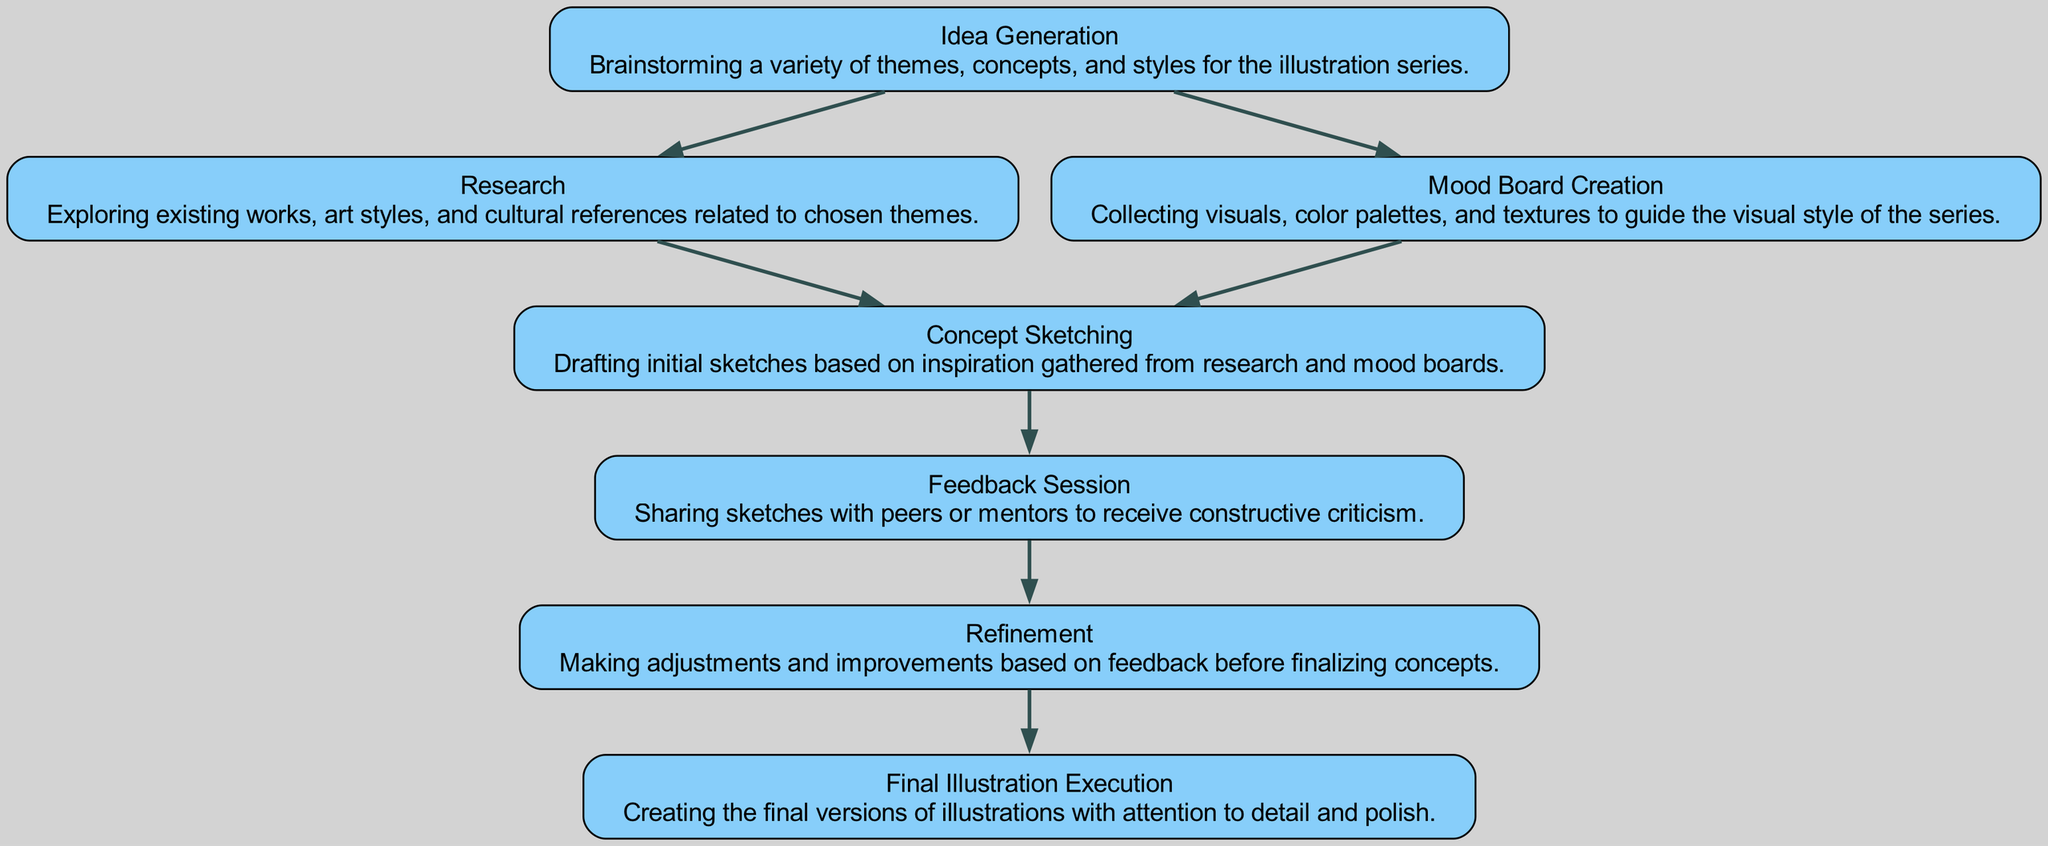What is the first step in the process? The first node in the diagram is "Idea Generation," which is where the process begins.
Answer: Idea Generation How many nodes are in the diagram? By counting each unique node in the diagram (from "Idea Generation" to "Final Illustration Execution"), there are seven nodes in total.
Answer: 7 What connects "Mood Board Creation" to "Concept Sketching"? "Mood Board Creation" is directly connected to "Concept Sketching" through an edge that indicates the flow from one step to the next.
Answer: Concept Sketching Which step follows “Feedback Session”? The diagram indicates that "Feedback Session" is followed by "Refinement," as shown by the directed edge connecting these two nodes.
Answer: Refinement What is the last step in the process? The final node in the directed graph is "Final Illustration Execution," which is the last step of the concept development process.
Answer: Final Illustration Execution How many edges are outgoing from "Research"? The node "Research" has one outgoing edge, which leads to "Concept Sketching," indicating that it flows to just one next step.
Answer: 1 What do "Research" and "Mood Board Creation" have in common? Both "Research" and "Mood Board Creation" serve as preceding steps that lead to the same next step, which is "Concept Sketching," indicating they are part of the preparation phase.
Answer: Concept Sketching Which step involves receiving feedback? The step that involves receiving feedback is specifically labeled as "Feedback Session," where constructive criticism is shared.
Answer: Feedback Session What is the direct relationship between "Concept Sketching" and "Refinement"? "Concept Sketching" directly leads to "Refinement," indicating that after sketching, the work is refined based on the initial concepts.
Answer: Refinement 